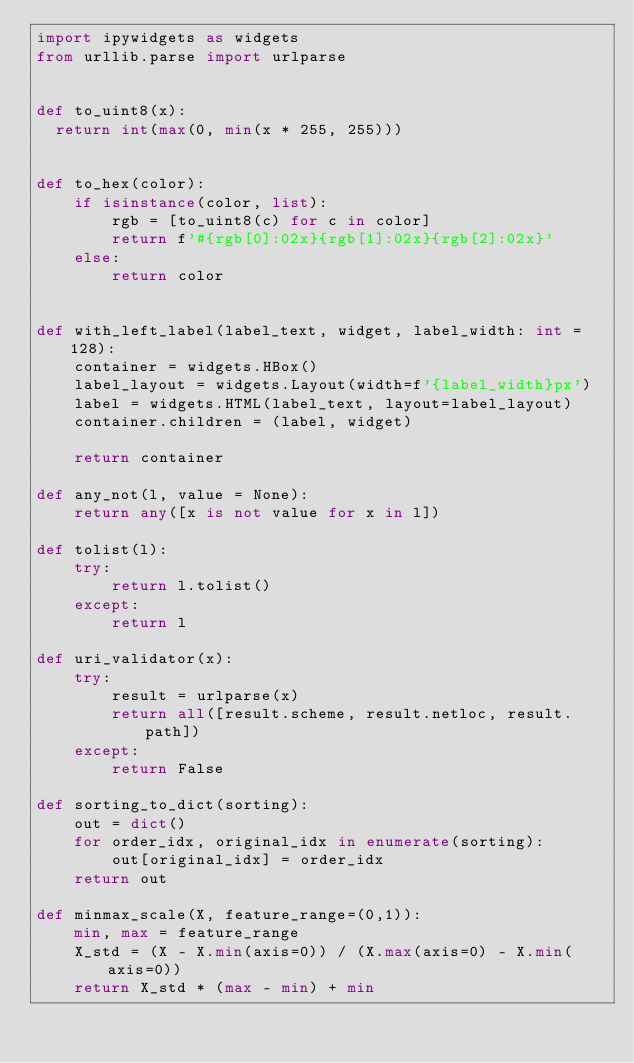Convert code to text. <code><loc_0><loc_0><loc_500><loc_500><_Python_>import ipywidgets as widgets
from urllib.parse import urlparse


def to_uint8(x):
  return int(max(0, min(x * 255, 255)))


def to_hex(color):
    if isinstance(color, list):
        rgb = [to_uint8(c) for c in color]
        return f'#{rgb[0]:02x}{rgb[1]:02x}{rgb[2]:02x}'
    else:
        return color


def with_left_label(label_text, widget, label_width: int = 128):
    container = widgets.HBox()
    label_layout = widgets.Layout(width=f'{label_width}px')
    label = widgets.HTML(label_text, layout=label_layout)
    container.children = (label, widget)

    return container

def any_not(l, value = None):
    return any([x is not value for x in l])

def tolist(l):
    try:
        return l.tolist()
    except:
        return l

def uri_validator(x):
    try:
        result = urlparse(x)
        return all([result.scheme, result.netloc, result.path])
    except:
        return False

def sorting_to_dict(sorting):
    out = dict()
    for order_idx, original_idx in enumerate(sorting):
        out[original_idx] = order_idx
    return out

def minmax_scale(X, feature_range=(0,1)):
    min, max = feature_range
    X_std = (X - X.min(axis=0)) / (X.max(axis=0) - X.min(axis=0))
    return X_std * (max - min) + min
</code> 